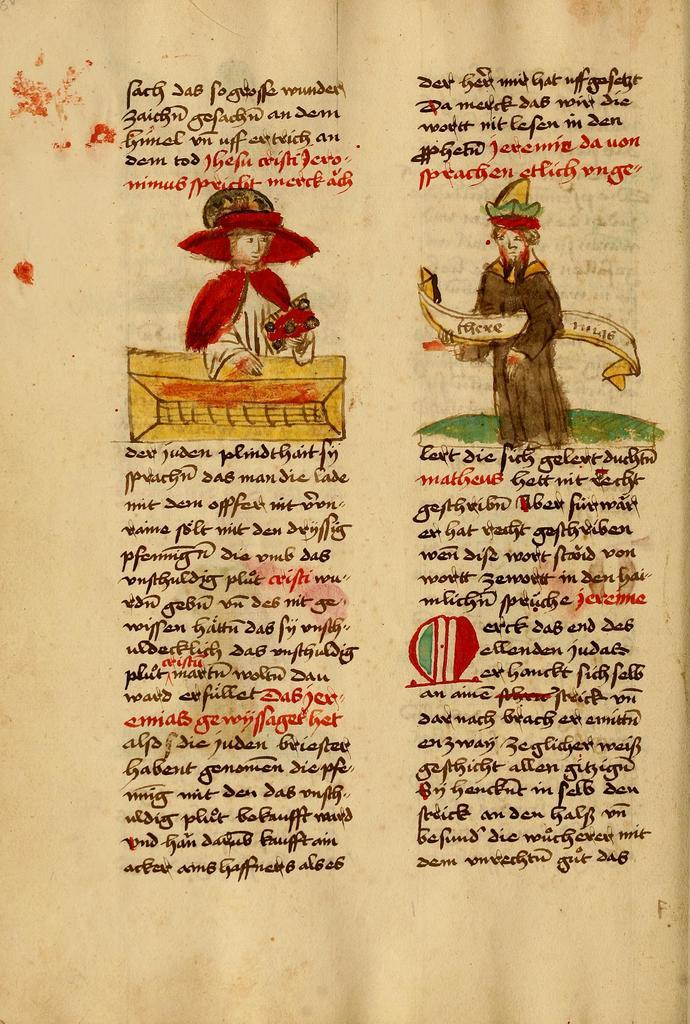What is the main object in the image? There is a paper in the image. What is depicted on the paper? The paper contains a depiction of persons. Is there any text on the paper? Yes, there is written text on the paper. What type of advice can be seen on the paper in the image? There is no advice present on the paper in the image; it contains a depiction of persons and written text. Can you see a wren perched on the paper in the image? There is no wren present in the image. 